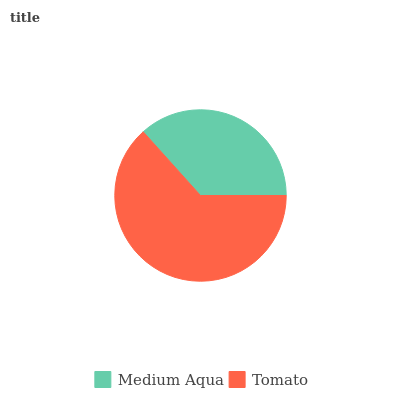Is Medium Aqua the minimum?
Answer yes or no. Yes. Is Tomato the maximum?
Answer yes or no. Yes. Is Tomato the minimum?
Answer yes or no. No. Is Tomato greater than Medium Aqua?
Answer yes or no. Yes. Is Medium Aqua less than Tomato?
Answer yes or no. Yes. Is Medium Aqua greater than Tomato?
Answer yes or no. No. Is Tomato less than Medium Aqua?
Answer yes or no. No. Is Tomato the high median?
Answer yes or no. Yes. Is Medium Aqua the low median?
Answer yes or no. Yes. Is Medium Aqua the high median?
Answer yes or no. No. Is Tomato the low median?
Answer yes or no. No. 